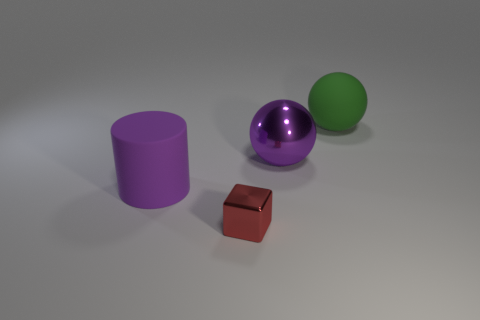What size is the thing left of the metal object on the left side of the big purple sphere?
Offer a very short reply. Large. Are there more big green objects to the right of the rubber ball than large cyan spheres?
Your answer should be compact. No. Do the rubber thing right of the red object and the large purple metal thing have the same size?
Offer a very short reply. Yes. There is a object that is both to the right of the big purple rubber thing and in front of the purple metallic sphere; what color is it?
Make the answer very short. Red. There is a green rubber object that is the same size as the purple metallic sphere; what is its shape?
Provide a succinct answer. Sphere. Are there any matte things that have the same color as the big cylinder?
Make the answer very short. No. Is the number of tiny objects in front of the small thing the same as the number of objects?
Your answer should be very brief. No. Do the small thing and the big metal ball have the same color?
Keep it short and to the point. No. There is a object that is both on the right side of the cylinder and in front of the big metallic sphere; what size is it?
Offer a terse response. Small. The sphere that is the same material as the big cylinder is what color?
Make the answer very short. Green. 